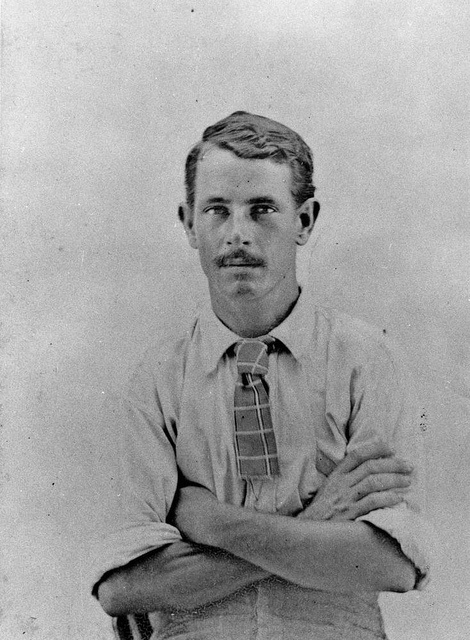Describe the objects in this image and their specific colors. I can see people in white, darkgray, gray, black, and lightgray tones and tie in gray, black, and white tones in this image. 